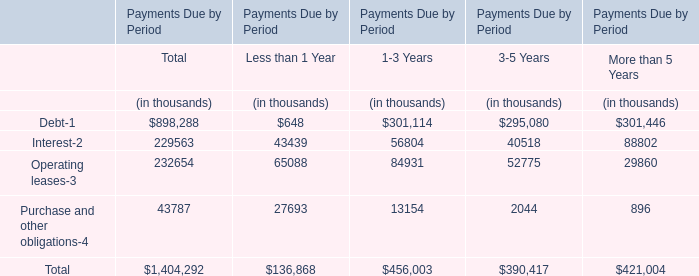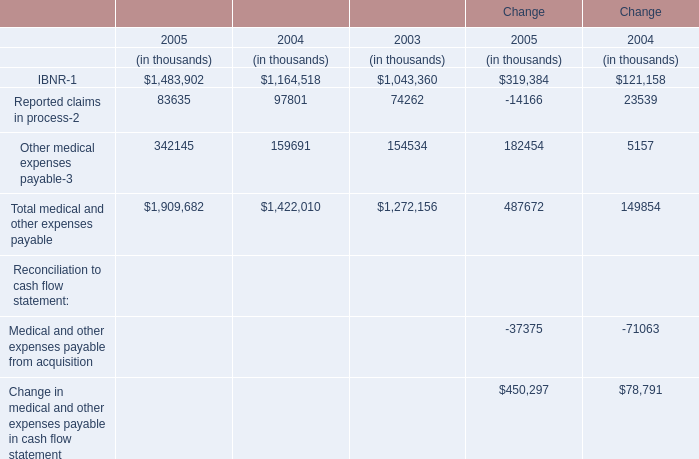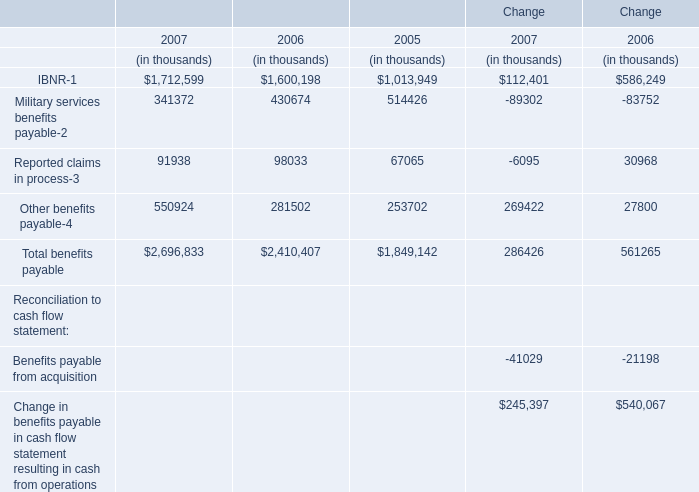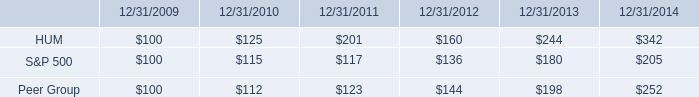What's the growth rate of Reported claims in process in 2007? 
Computations: ((91938 - 98033) / 98033)
Answer: -0.06217. 